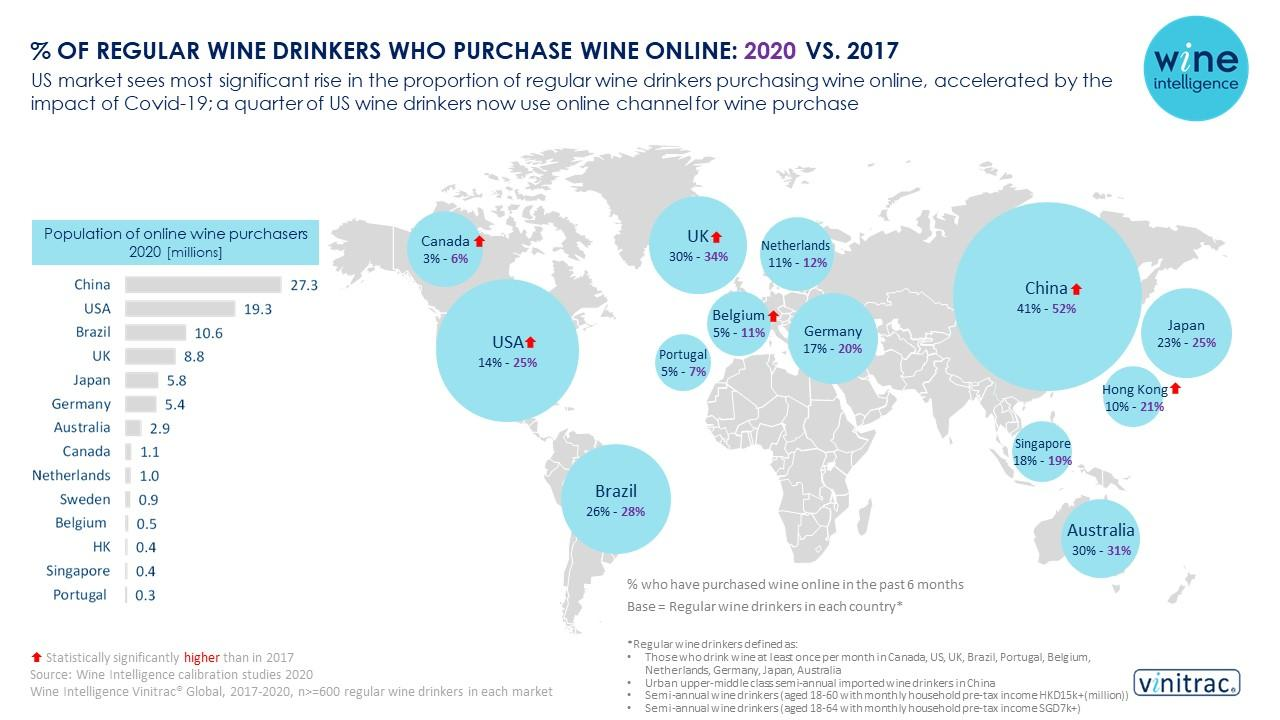Give some essential details in this illustration. In 2020, the population of online wine purchasers in Brazil was estimated to be approximately 10.6 million. According to the latest data, Singapore has the second lowest number of online wine purchasers in 2020, with a population of millions. In the year 2017, 18% of regular wine drinkers in Singapore purchased wine online. In 2020, it was found that 11% of regular wine drinkers in Belgium purchased wine online. The country with the least number of online wine purchasers in 2020 is Portugal, with approximately 1.5 million people. 